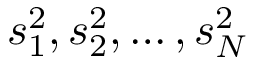<formula> <loc_0><loc_0><loc_500><loc_500>s _ { 1 } ^ { 2 } , s _ { 2 } ^ { 2 } , \dots , s _ { N } ^ { 2 }</formula> 